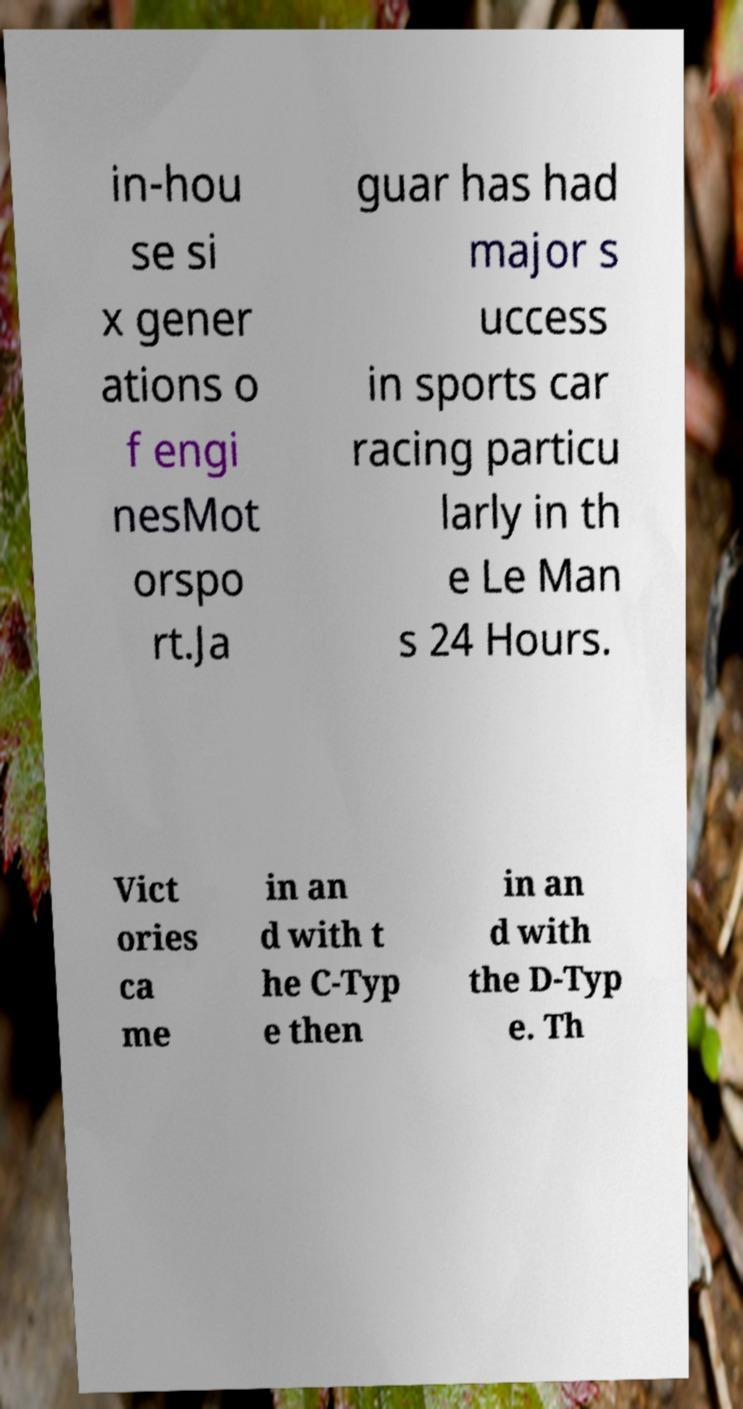Could you extract and type out the text from this image? in-hou se si x gener ations o f engi nesMot orspo rt.Ja guar has had major s uccess in sports car racing particu larly in th e Le Man s 24 Hours. Vict ories ca me in an d with t he C-Typ e then in an d with the D-Typ e. Th 